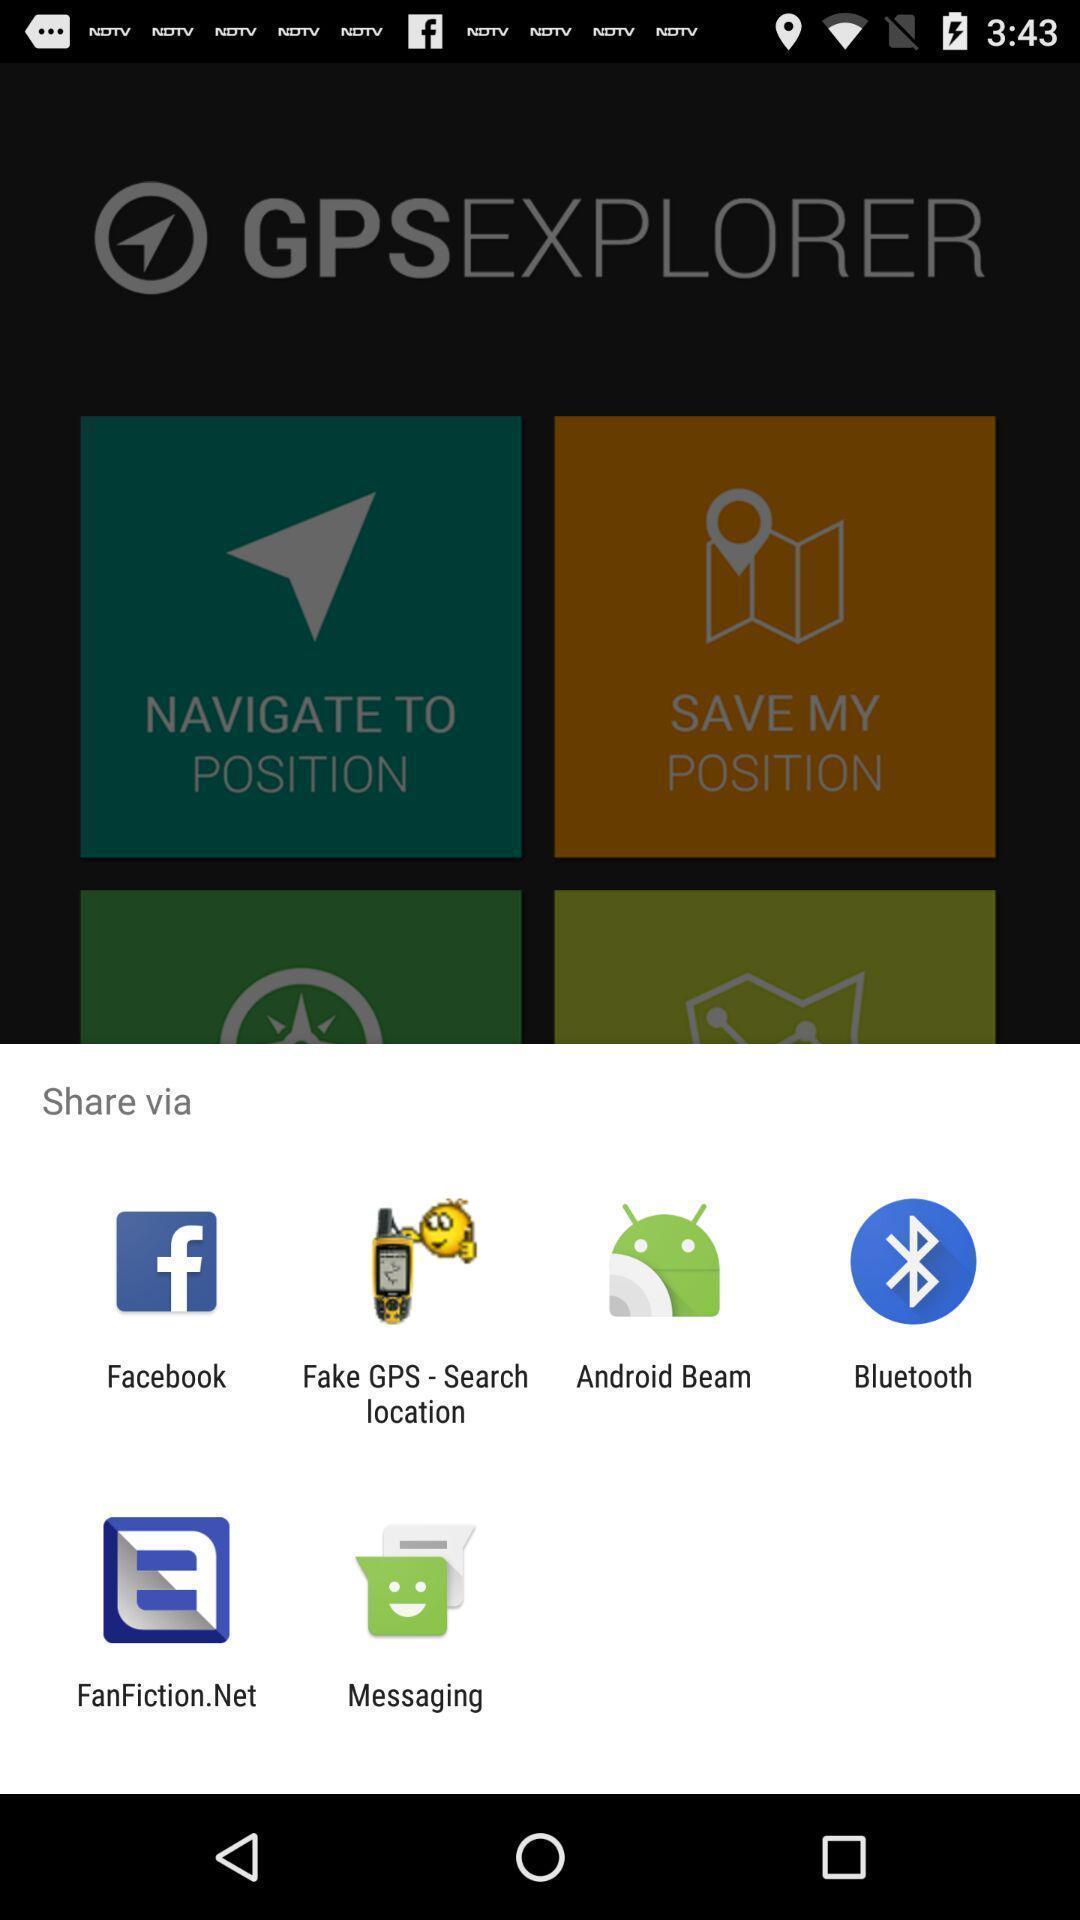What can you discern from this picture? Pop-up showing the multiple share options. 